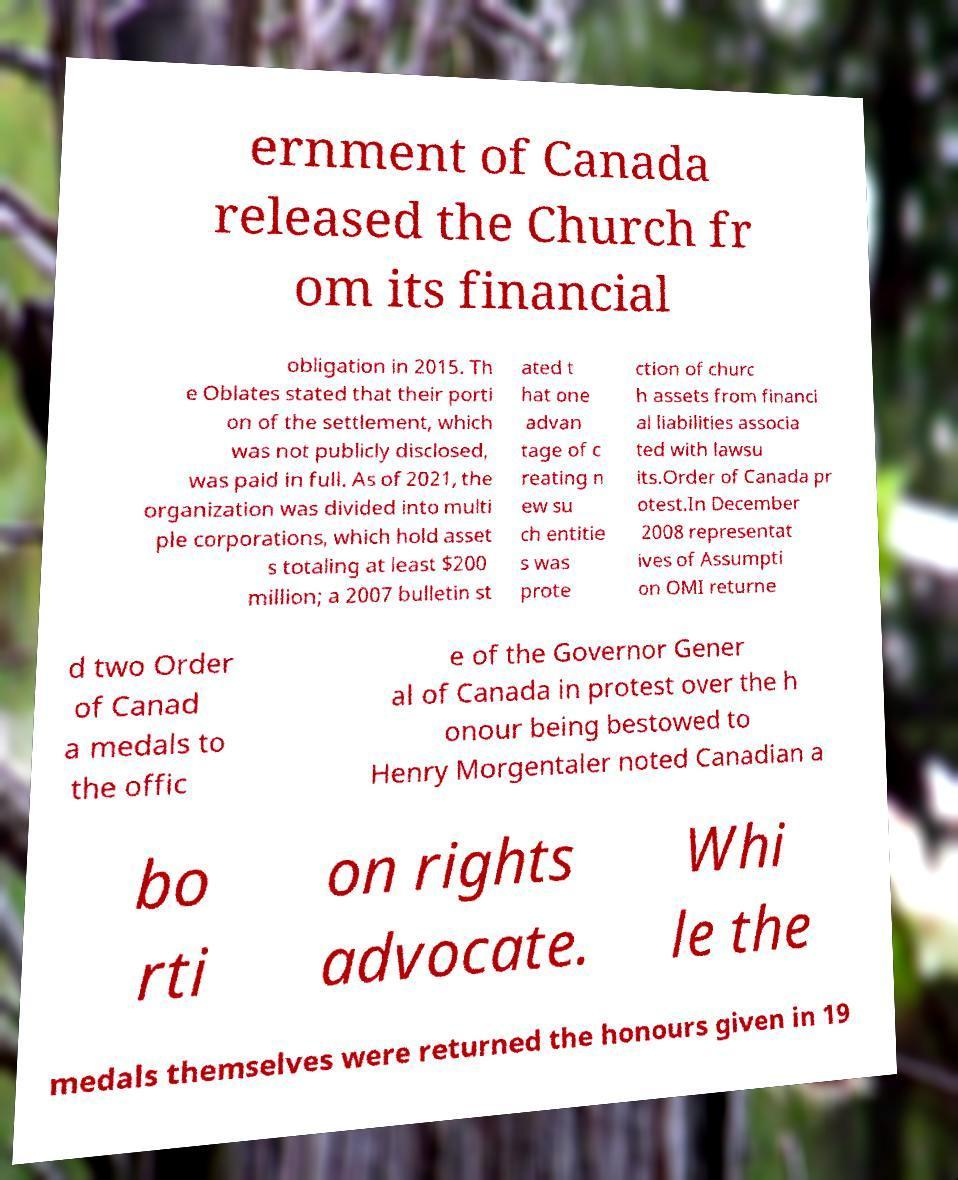Can you accurately transcribe the text from the provided image for me? ernment of Canada released the Church fr om its financial obligation in 2015. Th e Oblates stated that their porti on of the settlement, which was not publicly disclosed, was paid in full. As of 2021, the organization was divided into multi ple corporations, which hold asset s totaling at least $200 million; a 2007 bulletin st ated t hat one advan tage of c reating n ew su ch entitie s was prote ction of churc h assets from financi al liabilities associa ted with lawsu its.Order of Canada pr otest.In December 2008 representat ives of Assumpti on OMI returne d two Order of Canad a medals to the offic e of the Governor Gener al of Canada in protest over the h onour being bestowed to Henry Morgentaler noted Canadian a bo rti on rights advocate. Whi le the medals themselves were returned the honours given in 19 